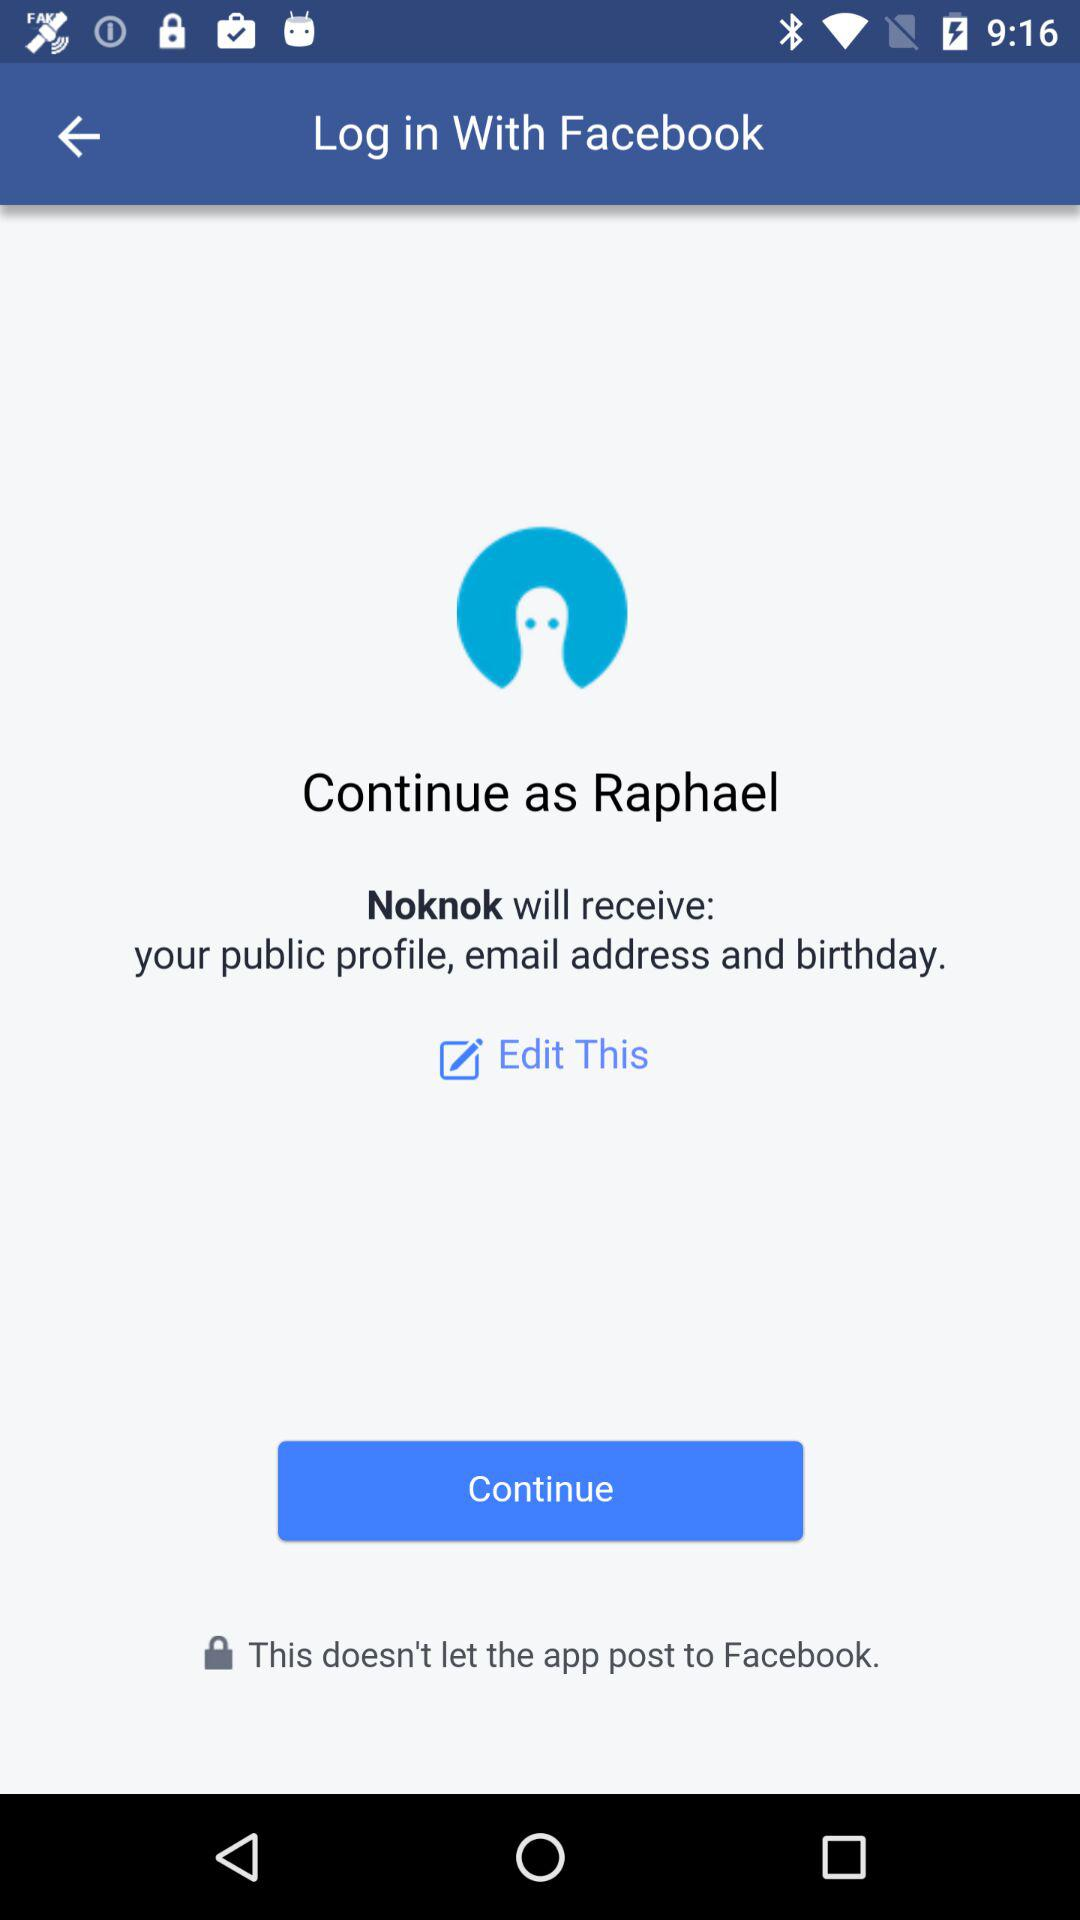What application will receive the person's personal information? The person's personal information will be received by "Noknok". 